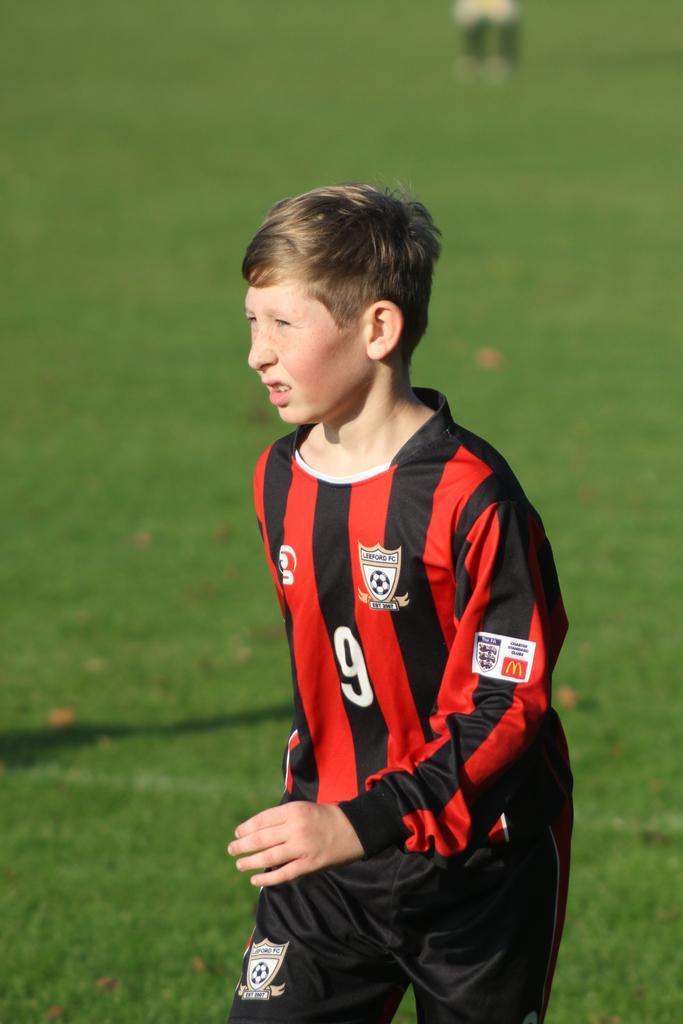In one or two sentences, can you explain what this image depicts? In the center of the image, we can see a person wearing a sports dress and in the background, there is ground. 